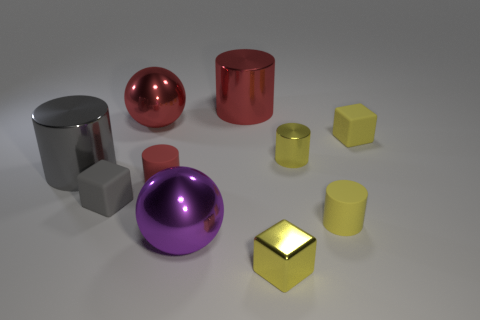There is a large purple object that is made of the same material as the big gray cylinder; what shape is it?
Ensure brevity in your answer.  Sphere. Does the big red cylinder have the same material as the red cylinder in front of the large red cylinder?
Your response must be concise. No. There is a tiny yellow block that is in front of the gray rubber cube; is there a small yellow rubber block that is in front of it?
Your response must be concise. No. What is the material of the other object that is the same shape as the purple shiny thing?
Make the answer very short. Metal. There is a red cylinder that is behind the gray shiny cylinder; how many large red metal cylinders are on the left side of it?
Make the answer very short. 0. Are there any other things of the same color as the small shiny block?
Provide a succinct answer. Yes. What number of things are either large red matte balls or tiny yellow metallic cylinders in front of the large red cylinder?
Provide a succinct answer. 1. What is the material of the gray object that is behind the tiny block left of the red cylinder that is left of the big red shiny cylinder?
Give a very brief answer. Metal. There is a purple object that is the same material as the big red sphere; what size is it?
Your response must be concise. Large. The large metal ball in front of the tiny yellow rubber thing that is in front of the tiny gray block is what color?
Your response must be concise. Purple. 